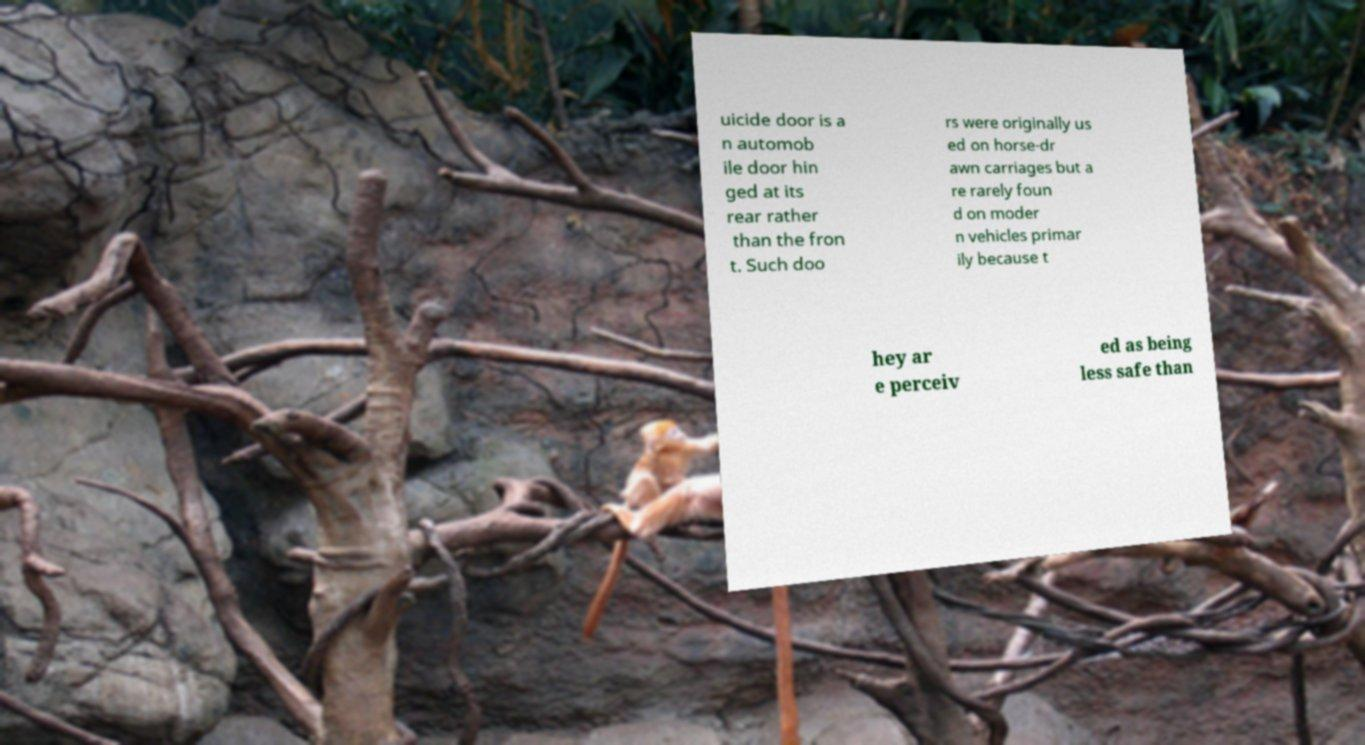For documentation purposes, I need the text within this image transcribed. Could you provide that? uicide door is a n automob ile door hin ged at its rear rather than the fron t. Such doo rs were originally us ed on horse-dr awn carriages but a re rarely foun d on moder n vehicles primar ily because t hey ar e perceiv ed as being less safe than 